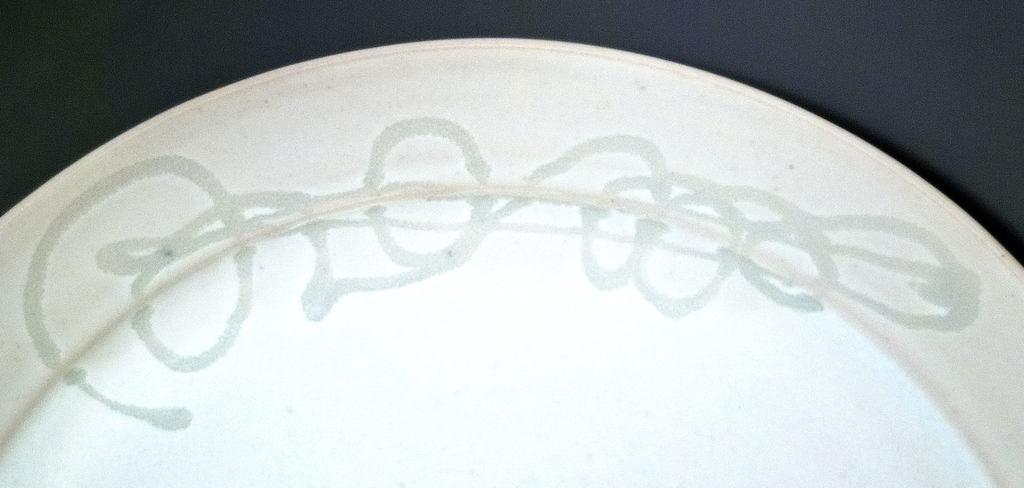Please provide a concise description of this image. This picture contains a plate which is white in color. This plate has some design. In the background, it is black in color. 